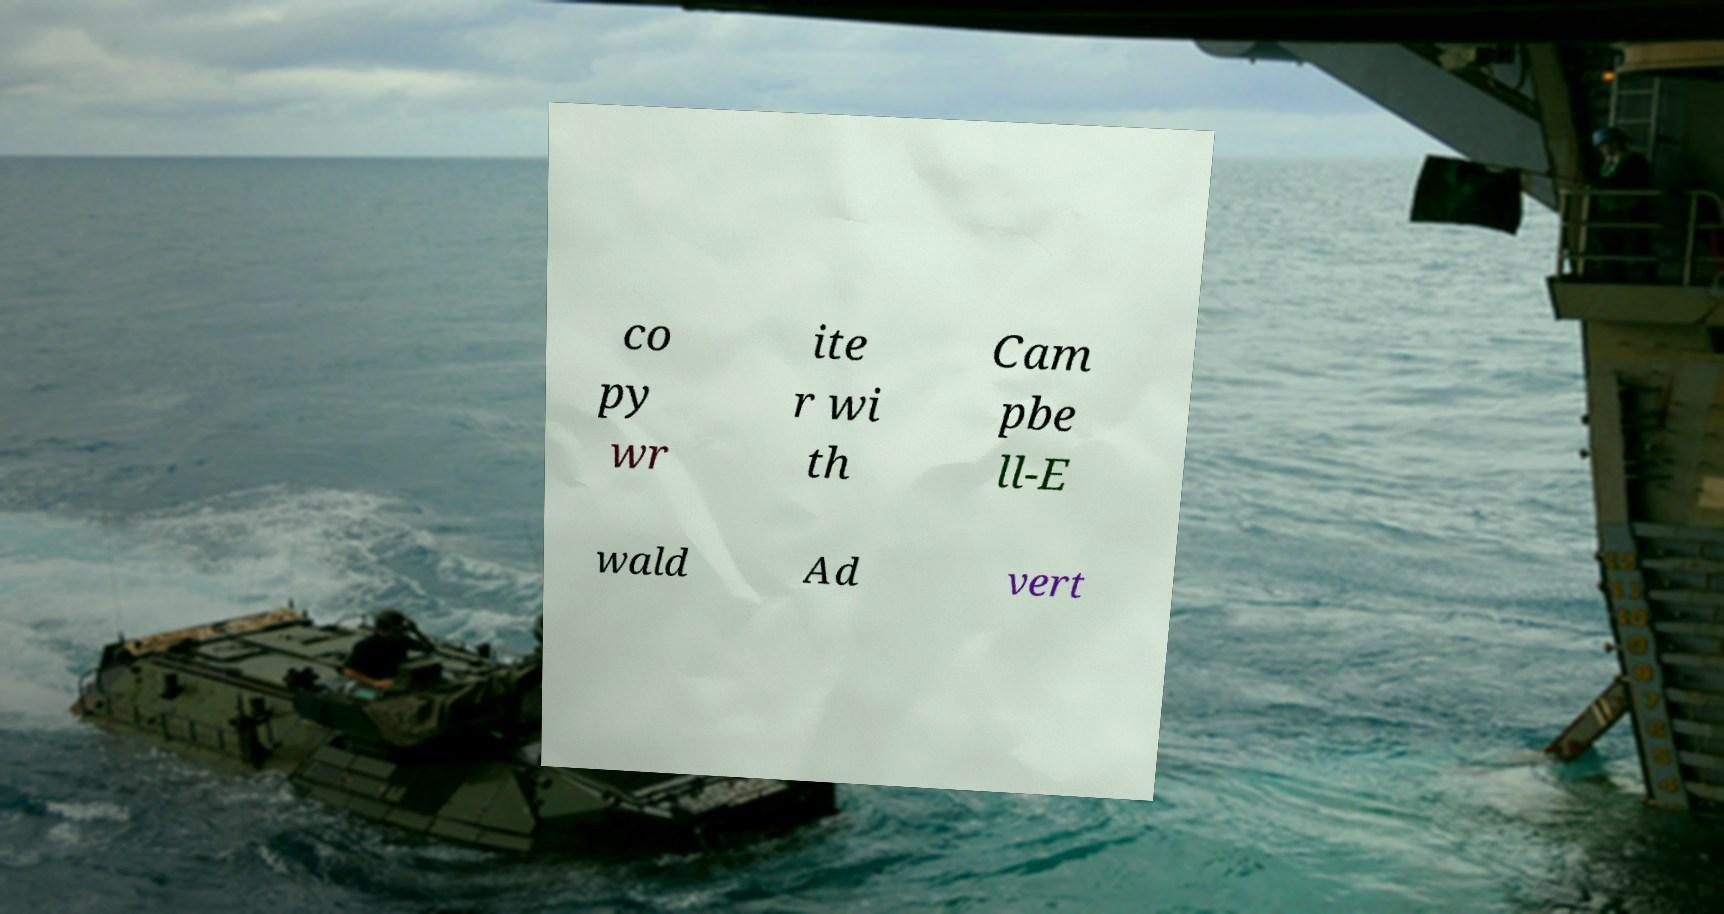Please read and relay the text visible in this image. What does it say? co py wr ite r wi th Cam pbe ll-E wald Ad vert 